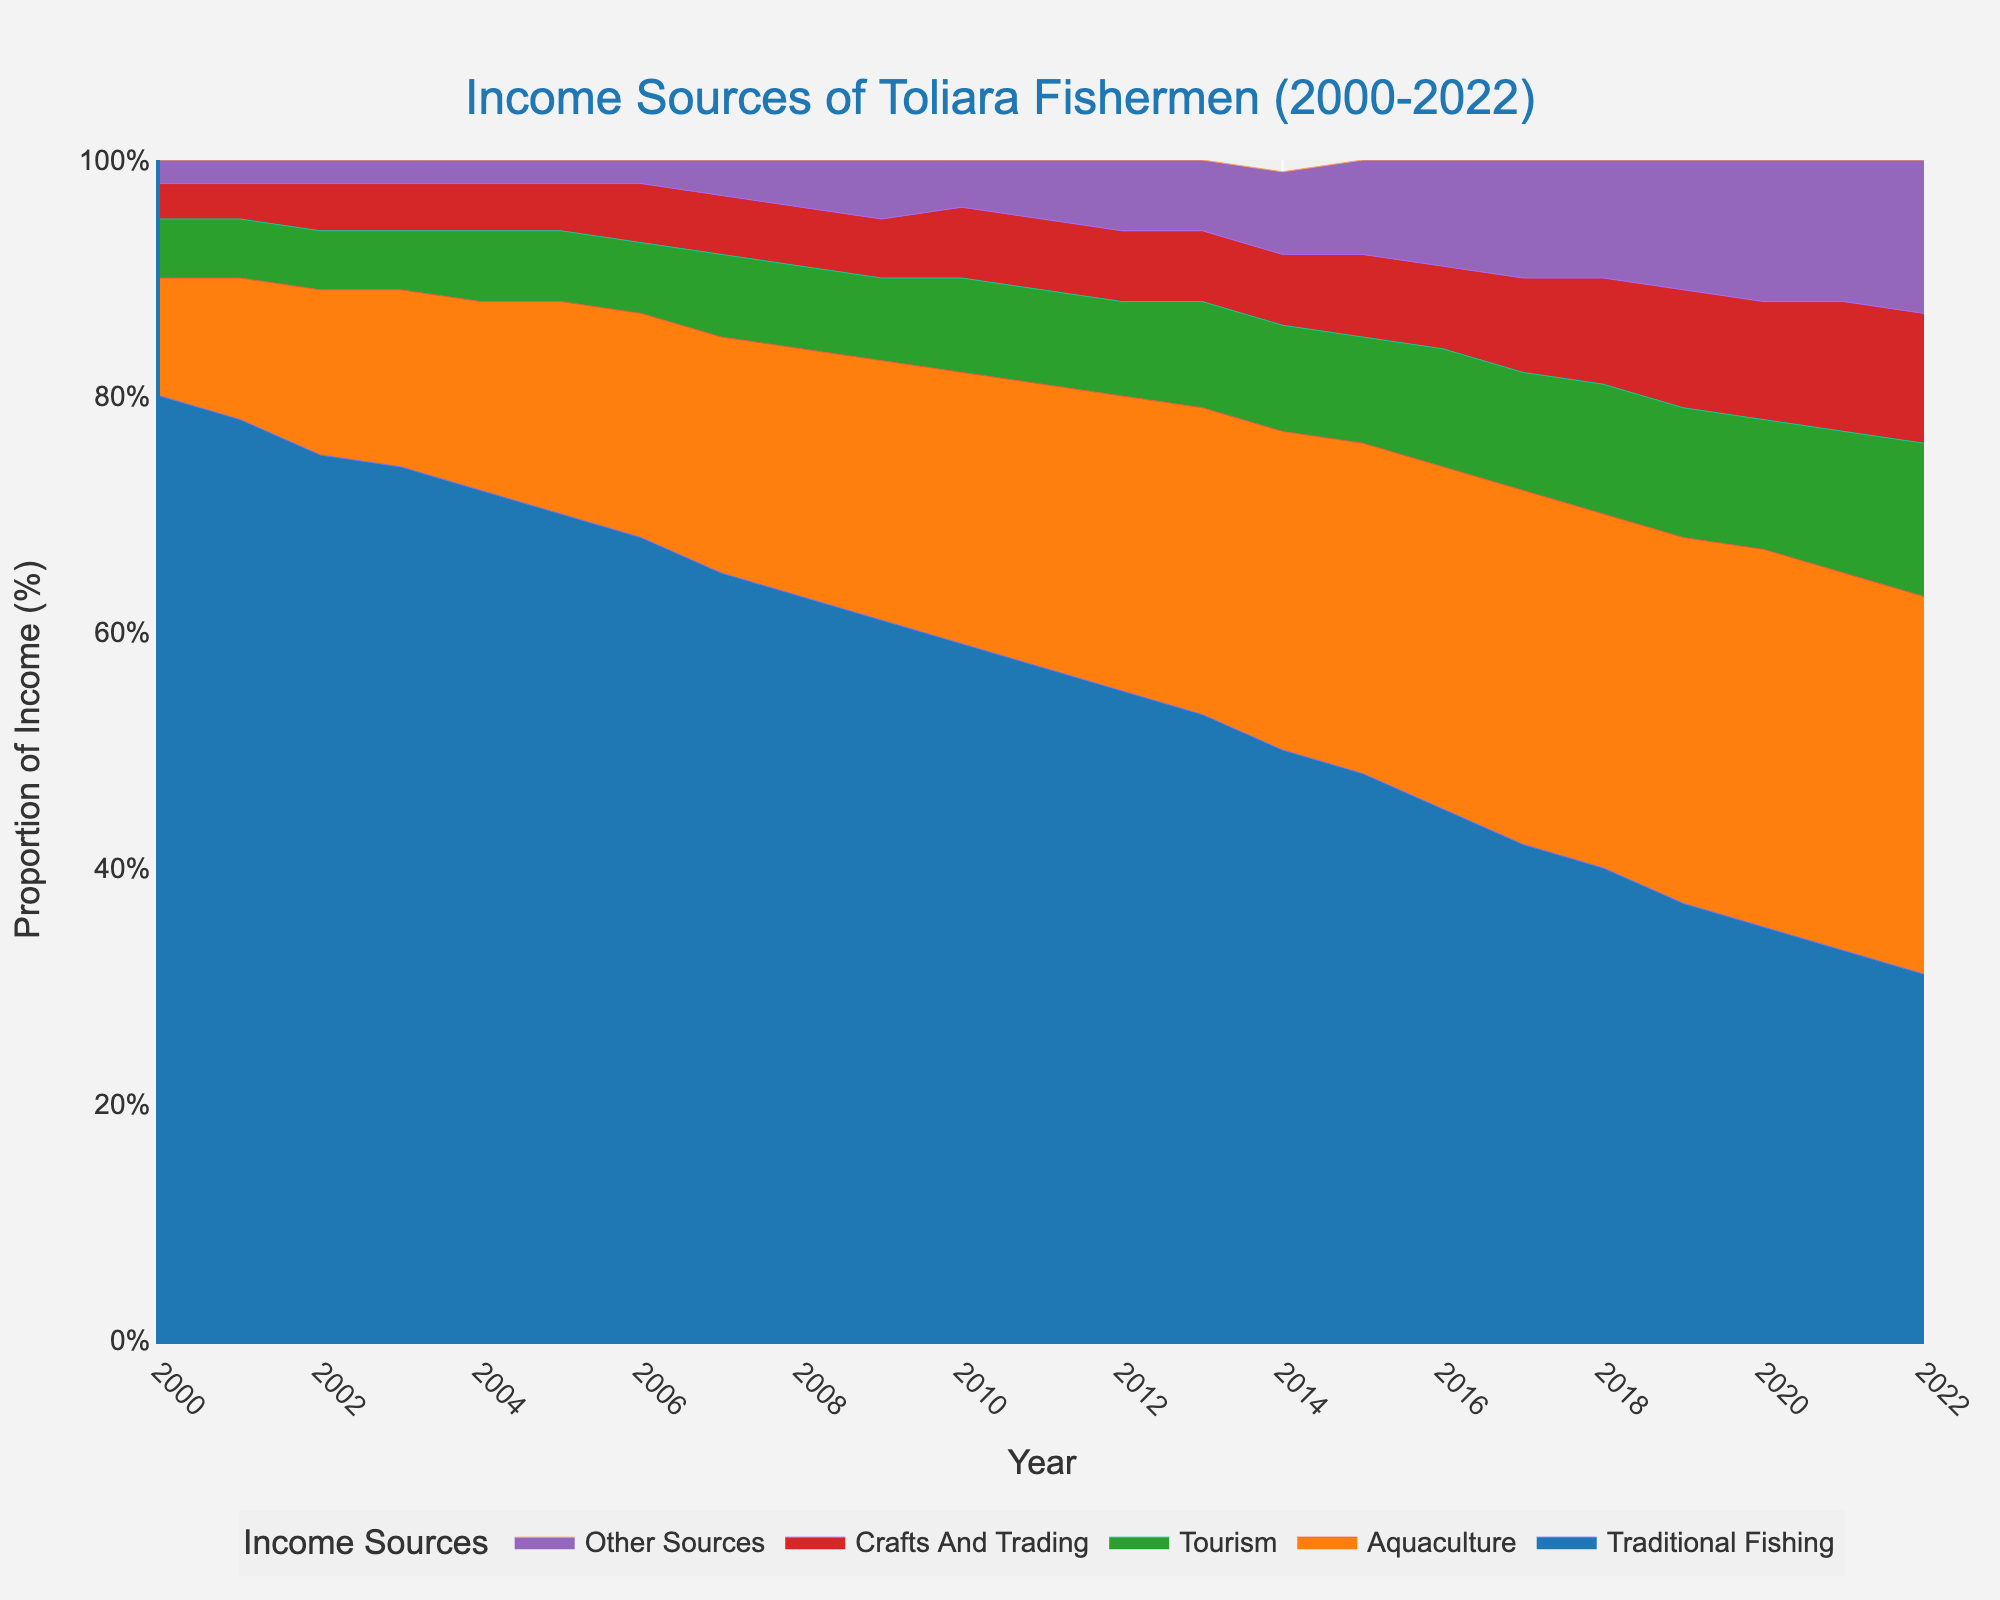what are the main income sources represented in the chart? The chart's legend lists the different income sources: Traditional Fishing, Aquaculture, Tourism, Crafts and Trading, and Other Sources.
Answer: Traditional Fishing, Aquaculture, Tourism, Crafts and Trading, Other Sources What year did traditional fishing first fall below 50%? To find this, look at the traditional fishing area in the chart. It falls below 50% in the year labeled 2014.
Answer: 2014 How has the proportion of aquaculture as an income source changed over time? The proportion of aquaculture increases steadily from 10% in 2000 to 32% in 2022.
Answer: Steadily increased Compare the proportion of income from crafts and trading in 2010 and 2020. Which year had a higher proportion? Look at the segment for Crafts and Trading for 2010 and 2020. In 2010 it was 6% while in 2020 it was 10%.
Answer: 2020 Which income source showed the most consistent share over the period? Inspect each colored segment to determine the one with the least variation. The 'Other Sources' segment remains relatively constant compared to others.
Answer: Other Sources What's the combined proportion of tourism and other sources in 2018? Add the proportions of tourism (11%) and other sources (10%) for 2018.
Answer: 21% When did aquaculture exceed 20% for the first time? Check the chart and find the first year where aquaculture surpasses 20%, which is in 2007.
Answer: 2007 In which years did the contribution of traditional fishing decline while aquaculture increased? From the chart, traditional fishing declines consistently and aquaculture increases steadily throughout the entire period from 2000 to 2022.
Answer: 2000-2022 If the trend continues, which income sources might be dominant in 2025? Based on visual trends, traditional fishing is declining, whereas aquaculture is increasing. If trends continue, aquaculture might be dominant.
Answer: Aquaculture How did the proportion of income from 'Crafts and Trading' change from 2000 to 2022? Compare the starting and ending points for 'Crafts and Trading'. It starts at 3% in 2000 and increases to 11% in 2022.
Answer: Increased from 3% to 11% 